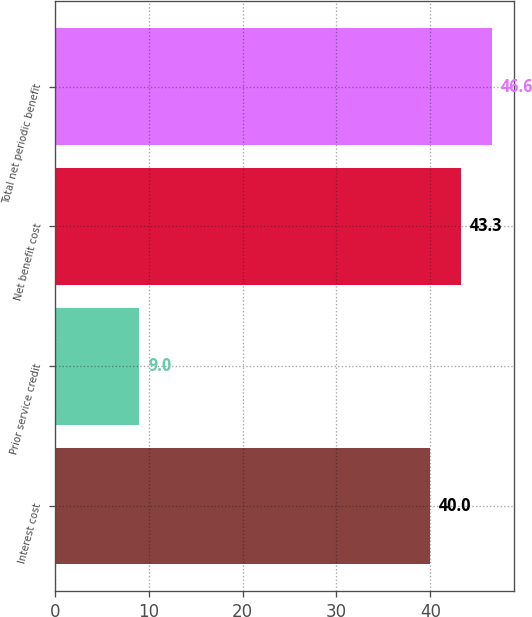Convert chart. <chart><loc_0><loc_0><loc_500><loc_500><bar_chart><fcel>Interest cost<fcel>Prior service credit<fcel>Net benefit cost<fcel>Total net periodic benefit<nl><fcel>40<fcel>9<fcel>43.3<fcel>46.6<nl></chart> 